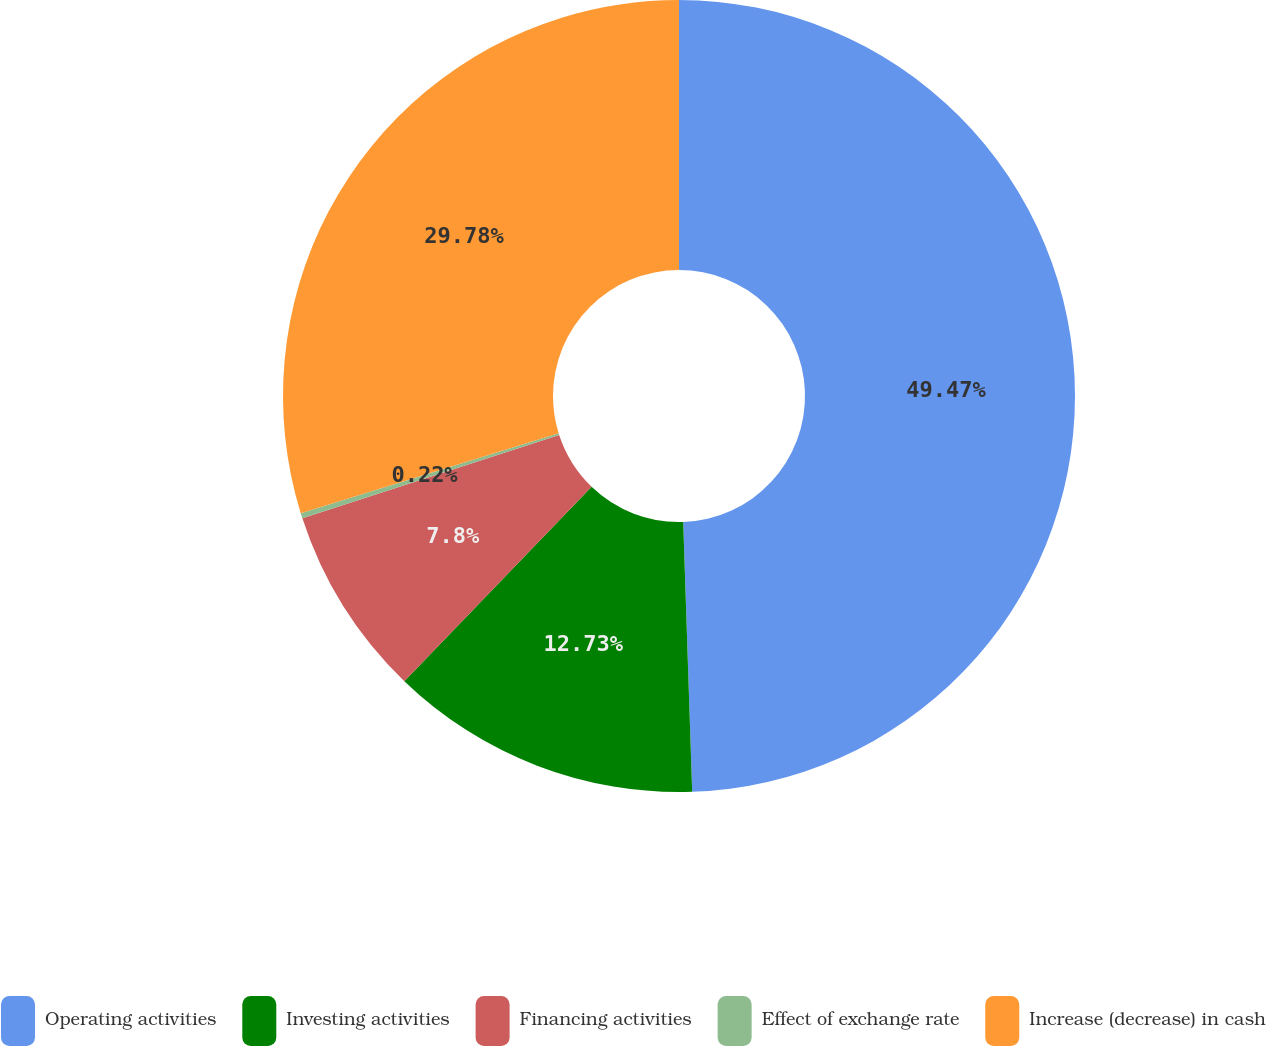<chart> <loc_0><loc_0><loc_500><loc_500><pie_chart><fcel>Operating activities<fcel>Investing activities<fcel>Financing activities<fcel>Effect of exchange rate<fcel>Increase (decrease) in cash<nl><fcel>49.47%<fcel>12.73%<fcel>7.8%<fcel>0.22%<fcel>29.78%<nl></chart> 